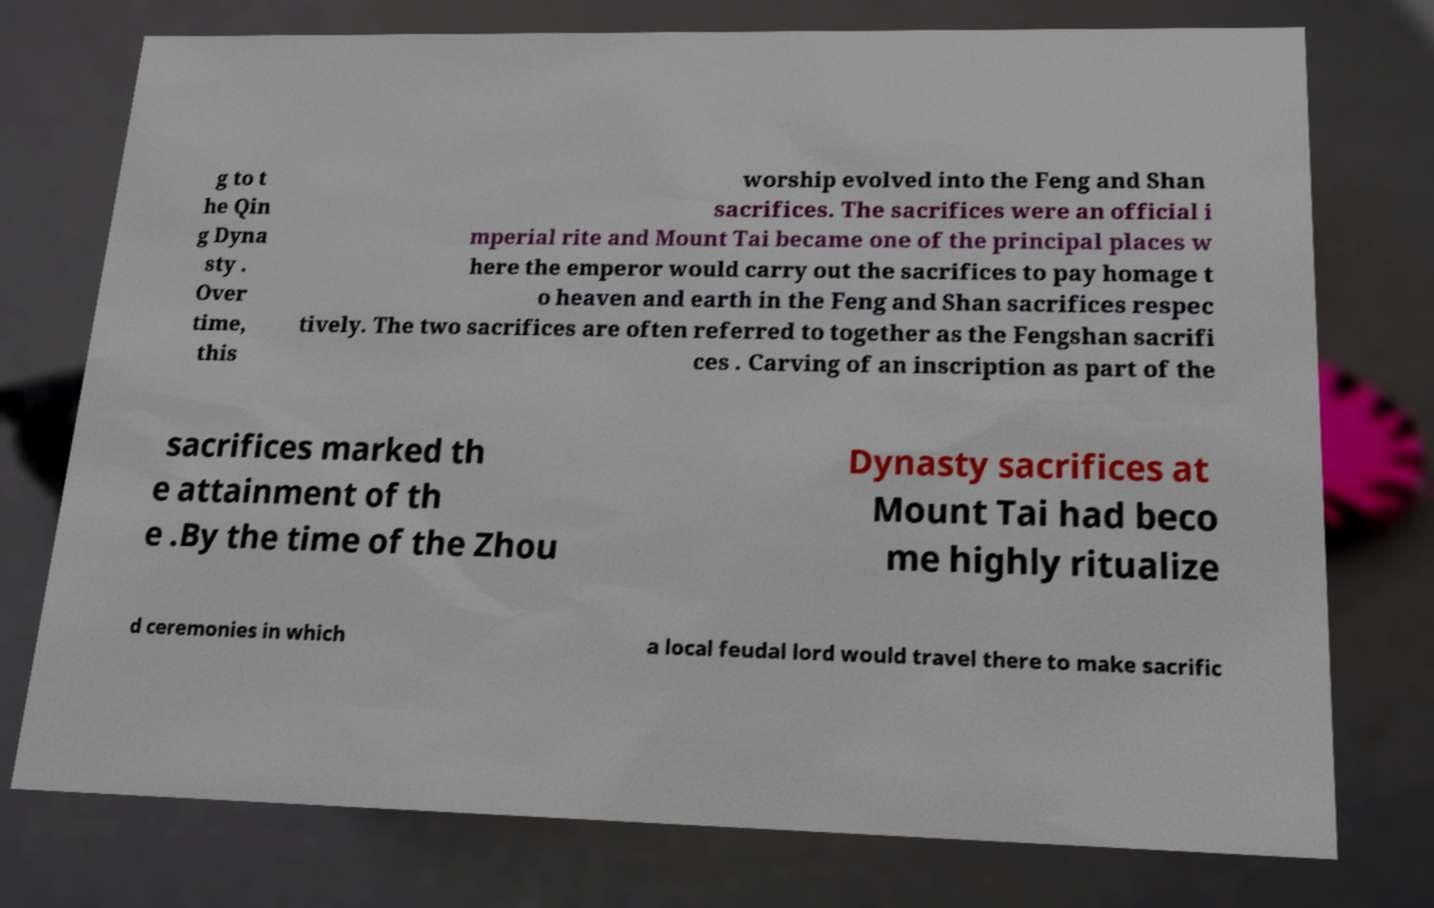Could you assist in decoding the text presented in this image and type it out clearly? g to t he Qin g Dyna sty . Over time, this worship evolved into the Feng and Shan sacrifices. The sacrifices were an official i mperial rite and Mount Tai became one of the principal places w here the emperor would carry out the sacrifices to pay homage t o heaven and earth in the Feng and Shan sacrifices respec tively. The two sacrifices are often referred to together as the Fengshan sacrifi ces . Carving of an inscription as part of the sacrifices marked th e attainment of th e .By the time of the Zhou Dynasty sacrifices at Mount Tai had beco me highly ritualize d ceremonies in which a local feudal lord would travel there to make sacrific 